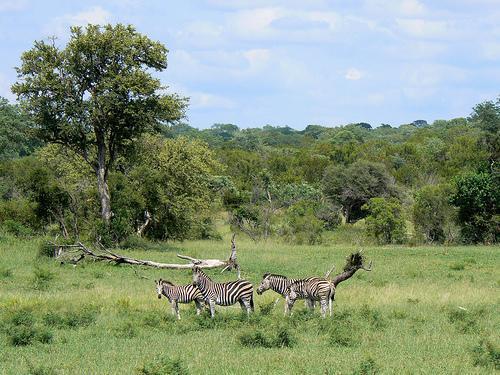How many zebras are in this photo?
Give a very brief answer. 4. 